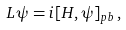<formula> <loc_0><loc_0><loc_500><loc_500>L \psi = i [ H , \psi ] _ { p b } \, ,</formula> 